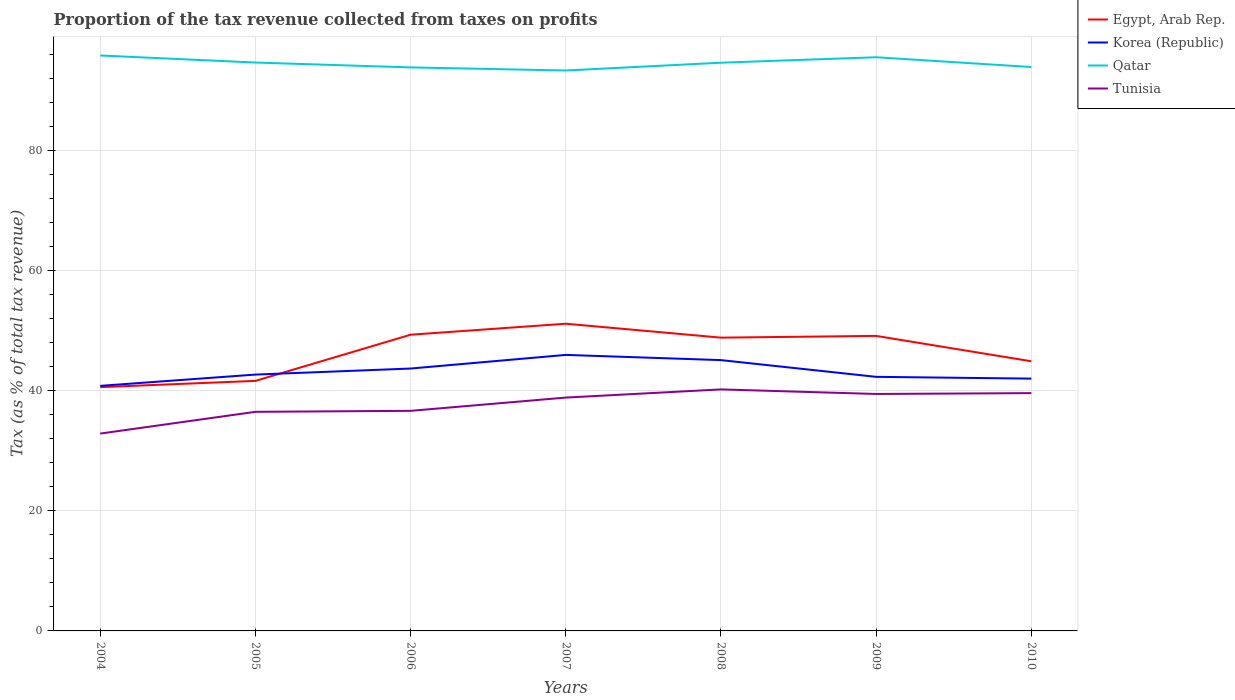Does the line corresponding to Qatar intersect with the line corresponding to Egypt, Arab Rep.?
Your answer should be very brief. No. Is the number of lines equal to the number of legend labels?
Your response must be concise. Yes. Across all years, what is the maximum proportion of the tax revenue collected in Tunisia?
Give a very brief answer. 32.89. In which year was the proportion of the tax revenue collected in Qatar maximum?
Your response must be concise. 2007. What is the total proportion of the tax revenue collected in Qatar in the graph?
Your answer should be compact. 1.33. What is the difference between the highest and the second highest proportion of the tax revenue collected in Tunisia?
Offer a terse response. 7.36. What is the difference between the highest and the lowest proportion of the tax revenue collected in Tunisia?
Keep it short and to the point. 4. Is the proportion of the tax revenue collected in Qatar strictly greater than the proportion of the tax revenue collected in Korea (Republic) over the years?
Your answer should be compact. No. How many lines are there?
Offer a very short reply. 4. Does the graph contain any zero values?
Provide a short and direct response. No. Does the graph contain grids?
Your answer should be compact. Yes. Where does the legend appear in the graph?
Give a very brief answer. Top right. How are the legend labels stacked?
Make the answer very short. Vertical. What is the title of the graph?
Provide a succinct answer. Proportion of the tax revenue collected from taxes on profits. What is the label or title of the Y-axis?
Offer a very short reply. Tax (as % of total tax revenue). What is the Tax (as % of total tax revenue) in Egypt, Arab Rep. in 2004?
Your answer should be very brief. 40.63. What is the Tax (as % of total tax revenue) in Korea (Republic) in 2004?
Your answer should be compact. 40.84. What is the Tax (as % of total tax revenue) of Qatar in 2004?
Keep it short and to the point. 95.9. What is the Tax (as % of total tax revenue) of Tunisia in 2004?
Your answer should be very brief. 32.89. What is the Tax (as % of total tax revenue) of Egypt, Arab Rep. in 2005?
Offer a terse response. 41.67. What is the Tax (as % of total tax revenue) of Korea (Republic) in 2005?
Keep it short and to the point. 42.72. What is the Tax (as % of total tax revenue) in Qatar in 2005?
Provide a succinct answer. 94.73. What is the Tax (as % of total tax revenue) in Tunisia in 2005?
Your response must be concise. 36.51. What is the Tax (as % of total tax revenue) of Egypt, Arab Rep. in 2006?
Provide a succinct answer. 49.37. What is the Tax (as % of total tax revenue) of Korea (Republic) in 2006?
Give a very brief answer. 43.73. What is the Tax (as % of total tax revenue) of Qatar in 2006?
Keep it short and to the point. 93.92. What is the Tax (as % of total tax revenue) in Tunisia in 2006?
Give a very brief answer. 36.68. What is the Tax (as % of total tax revenue) in Egypt, Arab Rep. in 2007?
Give a very brief answer. 51.2. What is the Tax (as % of total tax revenue) of Korea (Republic) in 2007?
Your answer should be compact. 46. What is the Tax (as % of total tax revenue) in Qatar in 2007?
Your answer should be compact. 93.4. What is the Tax (as % of total tax revenue) in Tunisia in 2007?
Offer a very short reply. 38.89. What is the Tax (as % of total tax revenue) in Egypt, Arab Rep. in 2008?
Provide a succinct answer. 48.88. What is the Tax (as % of total tax revenue) of Korea (Republic) in 2008?
Give a very brief answer. 45.13. What is the Tax (as % of total tax revenue) in Qatar in 2008?
Keep it short and to the point. 94.7. What is the Tax (as % of total tax revenue) of Tunisia in 2008?
Give a very brief answer. 40.25. What is the Tax (as % of total tax revenue) of Egypt, Arab Rep. in 2009?
Provide a succinct answer. 49.17. What is the Tax (as % of total tax revenue) of Korea (Republic) in 2009?
Make the answer very short. 42.34. What is the Tax (as % of total tax revenue) in Qatar in 2009?
Your response must be concise. 95.61. What is the Tax (as % of total tax revenue) in Tunisia in 2009?
Keep it short and to the point. 39.49. What is the Tax (as % of total tax revenue) of Egypt, Arab Rep. in 2010?
Give a very brief answer. 44.94. What is the Tax (as % of total tax revenue) in Korea (Republic) in 2010?
Give a very brief answer. 42.05. What is the Tax (as % of total tax revenue) in Qatar in 2010?
Keep it short and to the point. 93.98. What is the Tax (as % of total tax revenue) in Tunisia in 2010?
Keep it short and to the point. 39.63. Across all years, what is the maximum Tax (as % of total tax revenue) of Egypt, Arab Rep.?
Offer a terse response. 51.2. Across all years, what is the maximum Tax (as % of total tax revenue) in Korea (Republic)?
Offer a terse response. 46. Across all years, what is the maximum Tax (as % of total tax revenue) in Qatar?
Make the answer very short. 95.9. Across all years, what is the maximum Tax (as % of total tax revenue) of Tunisia?
Keep it short and to the point. 40.25. Across all years, what is the minimum Tax (as % of total tax revenue) of Egypt, Arab Rep.?
Your answer should be very brief. 40.63. Across all years, what is the minimum Tax (as % of total tax revenue) of Korea (Republic)?
Offer a very short reply. 40.84. Across all years, what is the minimum Tax (as % of total tax revenue) of Qatar?
Your response must be concise. 93.4. Across all years, what is the minimum Tax (as % of total tax revenue) in Tunisia?
Your answer should be very brief. 32.89. What is the total Tax (as % of total tax revenue) of Egypt, Arab Rep. in the graph?
Keep it short and to the point. 325.85. What is the total Tax (as % of total tax revenue) in Korea (Republic) in the graph?
Your answer should be compact. 302.82. What is the total Tax (as % of total tax revenue) in Qatar in the graph?
Offer a very short reply. 662.24. What is the total Tax (as % of total tax revenue) in Tunisia in the graph?
Your answer should be very brief. 264.35. What is the difference between the Tax (as % of total tax revenue) in Egypt, Arab Rep. in 2004 and that in 2005?
Make the answer very short. -1.05. What is the difference between the Tax (as % of total tax revenue) of Korea (Republic) in 2004 and that in 2005?
Make the answer very short. -1.88. What is the difference between the Tax (as % of total tax revenue) of Qatar in 2004 and that in 2005?
Keep it short and to the point. 1.18. What is the difference between the Tax (as % of total tax revenue) of Tunisia in 2004 and that in 2005?
Your answer should be compact. -3.62. What is the difference between the Tax (as % of total tax revenue) of Egypt, Arab Rep. in 2004 and that in 2006?
Offer a very short reply. -8.74. What is the difference between the Tax (as % of total tax revenue) in Korea (Republic) in 2004 and that in 2006?
Provide a succinct answer. -2.89. What is the difference between the Tax (as % of total tax revenue) in Qatar in 2004 and that in 2006?
Give a very brief answer. 1.99. What is the difference between the Tax (as % of total tax revenue) in Tunisia in 2004 and that in 2006?
Your answer should be very brief. -3.79. What is the difference between the Tax (as % of total tax revenue) in Egypt, Arab Rep. in 2004 and that in 2007?
Ensure brevity in your answer.  -10.57. What is the difference between the Tax (as % of total tax revenue) in Korea (Republic) in 2004 and that in 2007?
Your answer should be compact. -5.16. What is the difference between the Tax (as % of total tax revenue) of Qatar in 2004 and that in 2007?
Make the answer very short. 2.5. What is the difference between the Tax (as % of total tax revenue) in Tunisia in 2004 and that in 2007?
Offer a terse response. -6. What is the difference between the Tax (as % of total tax revenue) of Egypt, Arab Rep. in 2004 and that in 2008?
Keep it short and to the point. -8.25. What is the difference between the Tax (as % of total tax revenue) in Korea (Republic) in 2004 and that in 2008?
Provide a short and direct response. -4.29. What is the difference between the Tax (as % of total tax revenue) in Qatar in 2004 and that in 2008?
Make the answer very short. 1.2. What is the difference between the Tax (as % of total tax revenue) in Tunisia in 2004 and that in 2008?
Offer a terse response. -7.36. What is the difference between the Tax (as % of total tax revenue) of Egypt, Arab Rep. in 2004 and that in 2009?
Offer a very short reply. -8.54. What is the difference between the Tax (as % of total tax revenue) in Korea (Republic) in 2004 and that in 2009?
Provide a succinct answer. -1.5. What is the difference between the Tax (as % of total tax revenue) of Qatar in 2004 and that in 2009?
Provide a succinct answer. 0.29. What is the difference between the Tax (as % of total tax revenue) of Tunisia in 2004 and that in 2009?
Your answer should be compact. -6.6. What is the difference between the Tax (as % of total tax revenue) of Egypt, Arab Rep. in 2004 and that in 2010?
Offer a very short reply. -4.31. What is the difference between the Tax (as % of total tax revenue) in Korea (Republic) in 2004 and that in 2010?
Offer a very short reply. -1.21. What is the difference between the Tax (as % of total tax revenue) in Qatar in 2004 and that in 2010?
Provide a succinct answer. 1.92. What is the difference between the Tax (as % of total tax revenue) of Tunisia in 2004 and that in 2010?
Provide a succinct answer. -6.74. What is the difference between the Tax (as % of total tax revenue) of Egypt, Arab Rep. in 2005 and that in 2006?
Provide a short and direct response. -7.69. What is the difference between the Tax (as % of total tax revenue) in Korea (Republic) in 2005 and that in 2006?
Offer a very short reply. -1.01. What is the difference between the Tax (as % of total tax revenue) in Qatar in 2005 and that in 2006?
Ensure brevity in your answer.  0.81. What is the difference between the Tax (as % of total tax revenue) of Tunisia in 2005 and that in 2006?
Your answer should be very brief. -0.17. What is the difference between the Tax (as % of total tax revenue) of Egypt, Arab Rep. in 2005 and that in 2007?
Give a very brief answer. -9.53. What is the difference between the Tax (as % of total tax revenue) of Korea (Republic) in 2005 and that in 2007?
Keep it short and to the point. -3.28. What is the difference between the Tax (as % of total tax revenue) of Qatar in 2005 and that in 2007?
Offer a very short reply. 1.33. What is the difference between the Tax (as % of total tax revenue) of Tunisia in 2005 and that in 2007?
Provide a succinct answer. -2.38. What is the difference between the Tax (as % of total tax revenue) in Egypt, Arab Rep. in 2005 and that in 2008?
Your answer should be compact. -7.2. What is the difference between the Tax (as % of total tax revenue) in Korea (Republic) in 2005 and that in 2008?
Offer a terse response. -2.41. What is the difference between the Tax (as % of total tax revenue) of Qatar in 2005 and that in 2008?
Give a very brief answer. 0.03. What is the difference between the Tax (as % of total tax revenue) in Tunisia in 2005 and that in 2008?
Offer a terse response. -3.74. What is the difference between the Tax (as % of total tax revenue) in Egypt, Arab Rep. in 2005 and that in 2009?
Ensure brevity in your answer.  -7.5. What is the difference between the Tax (as % of total tax revenue) of Korea (Republic) in 2005 and that in 2009?
Offer a terse response. 0.38. What is the difference between the Tax (as % of total tax revenue) of Qatar in 2005 and that in 2009?
Provide a short and direct response. -0.88. What is the difference between the Tax (as % of total tax revenue) of Tunisia in 2005 and that in 2009?
Your answer should be very brief. -2.98. What is the difference between the Tax (as % of total tax revenue) in Egypt, Arab Rep. in 2005 and that in 2010?
Make the answer very short. -3.27. What is the difference between the Tax (as % of total tax revenue) in Korea (Republic) in 2005 and that in 2010?
Make the answer very short. 0.67. What is the difference between the Tax (as % of total tax revenue) in Qatar in 2005 and that in 2010?
Provide a short and direct response. 0.75. What is the difference between the Tax (as % of total tax revenue) in Tunisia in 2005 and that in 2010?
Your answer should be compact. -3.12. What is the difference between the Tax (as % of total tax revenue) in Egypt, Arab Rep. in 2006 and that in 2007?
Provide a short and direct response. -1.84. What is the difference between the Tax (as % of total tax revenue) of Korea (Republic) in 2006 and that in 2007?
Make the answer very short. -2.27. What is the difference between the Tax (as % of total tax revenue) in Qatar in 2006 and that in 2007?
Provide a short and direct response. 0.52. What is the difference between the Tax (as % of total tax revenue) of Tunisia in 2006 and that in 2007?
Give a very brief answer. -2.21. What is the difference between the Tax (as % of total tax revenue) of Egypt, Arab Rep. in 2006 and that in 2008?
Offer a very short reply. 0.49. What is the difference between the Tax (as % of total tax revenue) of Korea (Republic) in 2006 and that in 2008?
Make the answer very short. -1.4. What is the difference between the Tax (as % of total tax revenue) of Qatar in 2006 and that in 2008?
Offer a very short reply. -0.78. What is the difference between the Tax (as % of total tax revenue) in Tunisia in 2006 and that in 2008?
Your response must be concise. -3.57. What is the difference between the Tax (as % of total tax revenue) in Egypt, Arab Rep. in 2006 and that in 2009?
Provide a short and direct response. 0.2. What is the difference between the Tax (as % of total tax revenue) of Korea (Republic) in 2006 and that in 2009?
Your response must be concise. 1.39. What is the difference between the Tax (as % of total tax revenue) of Qatar in 2006 and that in 2009?
Your response must be concise. -1.69. What is the difference between the Tax (as % of total tax revenue) in Tunisia in 2006 and that in 2009?
Your answer should be very brief. -2.81. What is the difference between the Tax (as % of total tax revenue) in Egypt, Arab Rep. in 2006 and that in 2010?
Your response must be concise. 4.43. What is the difference between the Tax (as % of total tax revenue) of Korea (Republic) in 2006 and that in 2010?
Offer a terse response. 1.68. What is the difference between the Tax (as % of total tax revenue) in Qatar in 2006 and that in 2010?
Ensure brevity in your answer.  -0.06. What is the difference between the Tax (as % of total tax revenue) in Tunisia in 2006 and that in 2010?
Make the answer very short. -2.95. What is the difference between the Tax (as % of total tax revenue) in Egypt, Arab Rep. in 2007 and that in 2008?
Your response must be concise. 2.32. What is the difference between the Tax (as % of total tax revenue) of Korea (Republic) in 2007 and that in 2008?
Your answer should be compact. 0.87. What is the difference between the Tax (as % of total tax revenue) of Tunisia in 2007 and that in 2008?
Provide a short and direct response. -1.36. What is the difference between the Tax (as % of total tax revenue) in Egypt, Arab Rep. in 2007 and that in 2009?
Your answer should be compact. 2.03. What is the difference between the Tax (as % of total tax revenue) of Korea (Republic) in 2007 and that in 2009?
Provide a short and direct response. 3.66. What is the difference between the Tax (as % of total tax revenue) in Qatar in 2007 and that in 2009?
Your response must be concise. -2.21. What is the difference between the Tax (as % of total tax revenue) in Tunisia in 2007 and that in 2009?
Keep it short and to the point. -0.6. What is the difference between the Tax (as % of total tax revenue) of Egypt, Arab Rep. in 2007 and that in 2010?
Your answer should be compact. 6.26. What is the difference between the Tax (as % of total tax revenue) of Korea (Republic) in 2007 and that in 2010?
Your answer should be very brief. 3.95. What is the difference between the Tax (as % of total tax revenue) of Qatar in 2007 and that in 2010?
Make the answer very short. -0.58. What is the difference between the Tax (as % of total tax revenue) of Tunisia in 2007 and that in 2010?
Your answer should be very brief. -0.74. What is the difference between the Tax (as % of total tax revenue) of Egypt, Arab Rep. in 2008 and that in 2009?
Make the answer very short. -0.29. What is the difference between the Tax (as % of total tax revenue) of Korea (Republic) in 2008 and that in 2009?
Keep it short and to the point. 2.79. What is the difference between the Tax (as % of total tax revenue) of Qatar in 2008 and that in 2009?
Give a very brief answer. -0.91. What is the difference between the Tax (as % of total tax revenue) in Tunisia in 2008 and that in 2009?
Provide a short and direct response. 0.76. What is the difference between the Tax (as % of total tax revenue) of Egypt, Arab Rep. in 2008 and that in 2010?
Offer a terse response. 3.94. What is the difference between the Tax (as % of total tax revenue) of Korea (Republic) in 2008 and that in 2010?
Your response must be concise. 3.08. What is the difference between the Tax (as % of total tax revenue) in Qatar in 2008 and that in 2010?
Ensure brevity in your answer.  0.72. What is the difference between the Tax (as % of total tax revenue) in Tunisia in 2008 and that in 2010?
Give a very brief answer. 0.62. What is the difference between the Tax (as % of total tax revenue) in Egypt, Arab Rep. in 2009 and that in 2010?
Your response must be concise. 4.23. What is the difference between the Tax (as % of total tax revenue) of Korea (Republic) in 2009 and that in 2010?
Give a very brief answer. 0.29. What is the difference between the Tax (as % of total tax revenue) in Qatar in 2009 and that in 2010?
Make the answer very short. 1.63. What is the difference between the Tax (as % of total tax revenue) in Tunisia in 2009 and that in 2010?
Keep it short and to the point. -0.14. What is the difference between the Tax (as % of total tax revenue) of Egypt, Arab Rep. in 2004 and the Tax (as % of total tax revenue) of Korea (Republic) in 2005?
Your response must be concise. -2.09. What is the difference between the Tax (as % of total tax revenue) of Egypt, Arab Rep. in 2004 and the Tax (as % of total tax revenue) of Qatar in 2005?
Your answer should be compact. -54.1. What is the difference between the Tax (as % of total tax revenue) of Egypt, Arab Rep. in 2004 and the Tax (as % of total tax revenue) of Tunisia in 2005?
Your response must be concise. 4.11. What is the difference between the Tax (as % of total tax revenue) of Korea (Republic) in 2004 and the Tax (as % of total tax revenue) of Qatar in 2005?
Your response must be concise. -53.88. What is the difference between the Tax (as % of total tax revenue) of Korea (Republic) in 2004 and the Tax (as % of total tax revenue) of Tunisia in 2005?
Offer a terse response. 4.33. What is the difference between the Tax (as % of total tax revenue) of Qatar in 2004 and the Tax (as % of total tax revenue) of Tunisia in 2005?
Offer a very short reply. 59.39. What is the difference between the Tax (as % of total tax revenue) of Egypt, Arab Rep. in 2004 and the Tax (as % of total tax revenue) of Korea (Republic) in 2006?
Ensure brevity in your answer.  -3.1. What is the difference between the Tax (as % of total tax revenue) of Egypt, Arab Rep. in 2004 and the Tax (as % of total tax revenue) of Qatar in 2006?
Offer a terse response. -53.29. What is the difference between the Tax (as % of total tax revenue) in Egypt, Arab Rep. in 2004 and the Tax (as % of total tax revenue) in Tunisia in 2006?
Ensure brevity in your answer.  3.95. What is the difference between the Tax (as % of total tax revenue) of Korea (Republic) in 2004 and the Tax (as % of total tax revenue) of Qatar in 2006?
Make the answer very short. -53.07. What is the difference between the Tax (as % of total tax revenue) of Korea (Republic) in 2004 and the Tax (as % of total tax revenue) of Tunisia in 2006?
Provide a succinct answer. 4.16. What is the difference between the Tax (as % of total tax revenue) of Qatar in 2004 and the Tax (as % of total tax revenue) of Tunisia in 2006?
Provide a short and direct response. 59.22. What is the difference between the Tax (as % of total tax revenue) in Egypt, Arab Rep. in 2004 and the Tax (as % of total tax revenue) in Korea (Republic) in 2007?
Offer a terse response. -5.37. What is the difference between the Tax (as % of total tax revenue) in Egypt, Arab Rep. in 2004 and the Tax (as % of total tax revenue) in Qatar in 2007?
Ensure brevity in your answer.  -52.77. What is the difference between the Tax (as % of total tax revenue) in Egypt, Arab Rep. in 2004 and the Tax (as % of total tax revenue) in Tunisia in 2007?
Make the answer very short. 1.74. What is the difference between the Tax (as % of total tax revenue) of Korea (Republic) in 2004 and the Tax (as % of total tax revenue) of Qatar in 2007?
Keep it short and to the point. -52.56. What is the difference between the Tax (as % of total tax revenue) of Korea (Republic) in 2004 and the Tax (as % of total tax revenue) of Tunisia in 2007?
Keep it short and to the point. 1.95. What is the difference between the Tax (as % of total tax revenue) in Qatar in 2004 and the Tax (as % of total tax revenue) in Tunisia in 2007?
Provide a short and direct response. 57.01. What is the difference between the Tax (as % of total tax revenue) in Egypt, Arab Rep. in 2004 and the Tax (as % of total tax revenue) in Korea (Republic) in 2008?
Provide a short and direct response. -4.5. What is the difference between the Tax (as % of total tax revenue) in Egypt, Arab Rep. in 2004 and the Tax (as % of total tax revenue) in Qatar in 2008?
Your answer should be compact. -54.07. What is the difference between the Tax (as % of total tax revenue) in Egypt, Arab Rep. in 2004 and the Tax (as % of total tax revenue) in Tunisia in 2008?
Provide a succinct answer. 0.38. What is the difference between the Tax (as % of total tax revenue) in Korea (Republic) in 2004 and the Tax (as % of total tax revenue) in Qatar in 2008?
Keep it short and to the point. -53.86. What is the difference between the Tax (as % of total tax revenue) in Korea (Republic) in 2004 and the Tax (as % of total tax revenue) in Tunisia in 2008?
Keep it short and to the point. 0.59. What is the difference between the Tax (as % of total tax revenue) in Qatar in 2004 and the Tax (as % of total tax revenue) in Tunisia in 2008?
Make the answer very short. 55.65. What is the difference between the Tax (as % of total tax revenue) of Egypt, Arab Rep. in 2004 and the Tax (as % of total tax revenue) of Korea (Republic) in 2009?
Provide a succinct answer. -1.72. What is the difference between the Tax (as % of total tax revenue) in Egypt, Arab Rep. in 2004 and the Tax (as % of total tax revenue) in Qatar in 2009?
Ensure brevity in your answer.  -54.98. What is the difference between the Tax (as % of total tax revenue) in Egypt, Arab Rep. in 2004 and the Tax (as % of total tax revenue) in Tunisia in 2009?
Keep it short and to the point. 1.14. What is the difference between the Tax (as % of total tax revenue) of Korea (Republic) in 2004 and the Tax (as % of total tax revenue) of Qatar in 2009?
Provide a succinct answer. -54.77. What is the difference between the Tax (as % of total tax revenue) of Korea (Republic) in 2004 and the Tax (as % of total tax revenue) of Tunisia in 2009?
Your response must be concise. 1.35. What is the difference between the Tax (as % of total tax revenue) in Qatar in 2004 and the Tax (as % of total tax revenue) in Tunisia in 2009?
Provide a short and direct response. 56.41. What is the difference between the Tax (as % of total tax revenue) of Egypt, Arab Rep. in 2004 and the Tax (as % of total tax revenue) of Korea (Republic) in 2010?
Make the answer very short. -1.42. What is the difference between the Tax (as % of total tax revenue) of Egypt, Arab Rep. in 2004 and the Tax (as % of total tax revenue) of Qatar in 2010?
Make the answer very short. -53.35. What is the difference between the Tax (as % of total tax revenue) of Egypt, Arab Rep. in 2004 and the Tax (as % of total tax revenue) of Tunisia in 2010?
Offer a terse response. 1. What is the difference between the Tax (as % of total tax revenue) in Korea (Republic) in 2004 and the Tax (as % of total tax revenue) in Qatar in 2010?
Ensure brevity in your answer.  -53.13. What is the difference between the Tax (as % of total tax revenue) of Korea (Republic) in 2004 and the Tax (as % of total tax revenue) of Tunisia in 2010?
Offer a very short reply. 1.21. What is the difference between the Tax (as % of total tax revenue) of Qatar in 2004 and the Tax (as % of total tax revenue) of Tunisia in 2010?
Offer a very short reply. 56.27. What is the difference between the Tax (as % of total tax revenue) of Egypt, Arab Rep. in 2005 and the Tax (as % of total tax revenue) of Korea (Republic) in 2006?
Give a very brief answer. -2.06. What is the difference between the Tax (as % of total tax revenue) in Egypt, Arab Rep. in 2005 and the Tax (as % of total tax revenue) in Qatar in 2006?
Your answer should be very brief. -52.24. What is the difference between the Tax (as % of total tax revenue) in Egypt, Arab Rep. in 2005 and the Tax (as % of total tax revenue) in Tunisia in 2006?
Give a very brief answer. 4.99. What is the difference between the Tax (as % of total tax revenue) of Korea (Republic) in 2005 and the Tax (as % of total tax revenue) of Qatar in 2006?
Provide a succinct answer. -51.19. What is the difference between the Tax (as % of total tax revenue) of Korea (Republic) in 2005 and the Tax (as % of total tax revenue) of Tunisia in 2006?
Your answer should be very brief. 6.04. What is the difference between the Tax (as % of total tax revenue) of Qatar in 2005 and the Tax (as % of total tax revenue) of Tunisia in 2006?
Your response must be concise. 58.05. What is the difference between the Tax (as % of total tax revenue) of Egypt, Arab Rep. in 2005 and the Tax (as % of total tax revenue) of Korea (Republic) in 2007?
Give a very brief answer. -4.33. What is the difference between the Tax (as % of total tax revenue) of Egypt, Arab Rep. in 2005 and the Tax (as % of total tax revenue) of Qatar in 2007?
Ensure brevity in your answer.  -51.73. What is the difference between the Tax (as % of total tax revenue) in Egypt, Arab Rep. in 2005 and the Tax (as % of total tax revenue) in Tunisia in 2007?
Ensure brevity in your answer.  2.78. What is the difference between the Tax (as % of total tax revenue) of Korea (Republic) in 2005 and the Tax (as % of total tax revenue) of Qatar in 2007?
Your answer should be compact. -50.68. What is the difference between the Tax (as % of total tax revenue) of Korea (Republic) in 2005 and the Tax (as % of total tax revenue) of Tunisia in 2007?
Your answer should be very brief. 3.83. What is the difference between the Tax (as % of total tax revenue) in Qatar in 2005 and the Tax (as % of total tax revenue) in Tunisia in 2007?
Ensure brevity in your answer.  55.84. What is the difference between the Tax (as % of total tax revenue) in Egypt, Arab Rep. in 2005 and the Tax (as % of total tax revenue) in Korea (Republic) in 2008?
Offer a terse response. -3.46. What is the difference between the Tax (as % of total tax revenue) in Egypt, Arab Rep. in 2005 and the Tax (as % of total tax revenue) in Qatar in 2008?
Give a very brief answer. -53.03. What is the difference between the Tax (as % of total tax revenue) in Egypt, Arab Rep. in 2005 and the Tax (as % of total tax revenue) in Tunisia in 2008?
Offer a very short reply. 1.42. What is the difference between the Tax (as % of total tax revenue) in Korea (Republic) in 2005 and the Tax (as % of total tax revenue) in Qatar in 2008?
Give a very brief answer. -51.98. What is the difference between the Tax (as % of total tax revenue) of Korea (Republic) in 2005 and the Tax (as % of total tax revenue) of Tunisia in 2008?
Provide a succinct answer. 2.47. What is the difference between the Tax (as % of total tax revenue) of Qatar in 2005 and the Tax (as % of total tax revenue) of Tunisia in 2008?
Provide a short and direct response. 54.47. What is the difference between the Tax (as % of total tax revenue) in Egypt, Arab Rep. in 2005 and the Tax (as % of total tax revenue) in Korea (Republic) in 2009?
Ensure brevity in your answer.  -0.67. What is the difference between the Tax (as % of total tax revenue) in Egypt, Arab Rep. in 2005 and the Tax (as % of total tax revenue) in Qatar in 2009?
Your answer should be compact. -53.94. What is the difference between the Tax (as % of total tax revenue) of Egypt, Arab Rep. in 2005 and the Tax (as % of total tax revenue) of Tunisia in 2009?
Offer a very short reply. 2.18. What is the difference between the Tax (as % of total tax revenue) in Korea (Republic) in 2005 and the Tax (as % of total tax revenue) in Qatar in 2009?
Your answer should be very brief. -52.89. What is the difference between the Tax (as % of total tax revenue) in Korea (Republic) in 2005 and the Tax (as % of total tax revenue) in Tunisia in 2009?
Make the answer very short. 3.23. What is the difference between the Tax (as % of total tax revenue) of Qatar in 2005 and the Tax (as % of total tax revenue) of Tunisia in 2009?
Offer a terse response. 55.24. What is the difference between the Tax (as % of total tax revenue) in Egypt, Arab Rep. in 2005 and the Tax (as % of total tax revenue) in Korea (Republic) in 2010?
Your answer should be compact. -0.38. What is the difference between the Tax (as % of total tax revenue) of Egypt, Arab Rep. in 2005 and the Tax (as % of total tax revenue) of Qatar in 2010?
Provide a short and direct response. -52.31. What is the difference between the Tax (as % of total tax revenue) of Egypt, Arab Rep. in 2005 and the Tax (as % of total tax revenue) of Tunisia in 2010?
Make the answer very short. 2.04. What is the difference between the Tax (as % of total tax revenue) of Korea (Republic) in 2005 and the Tax (as % of total tax revenue) of Qatar in 2010?
Your answer should be compact. -51.26. What is the difference between the Tax (as % of total tax revenue) of Korea (Republic) in 2005 and the Tax (as % of total tax revenue) of Tunisia in 2010?
Keep it short and to the point. 3.09. What is the difference between the Tax (as % of total tax revenue) of Qatar in 2005 and the Tax (as % of total tax revenue) of Tunisia in 2010?
Give a very brief answer. 55.09. What is the difference between the Tax (as % of total tax revenue) of Egypt, Arab Rep. in 2006 and the Tax (as % of total tax revenue) of Korea (Republic) in 2007?
Provide a short and direct response. 3.36. What is the difference between the Tax (as % of total tax revenue) in Egypt, Arab Rep. in 2006 and the Tax (as % of total tax revenue) in Qatar in 2007?
Make the answer very short. -44.04. What is the difference between the Tax (as % of total tax revenue) of Egypt, Arab Rep. in 2006 and the Tax (as % of total tax revenue) of Tunisia in 2007?
Give a very brief answer. 10.47. What is the difference between the Tax (as % of total tax revenue) in Korea (Republic) in 2006 and the Tax (as % of total tax revenue) in Qatar in 2007?
Your answer should be compact. -49.67. What is the difference between the Tax (as % of total tax revenue) of Korea (Republic) in 2006 and the Tax (as % of total tax revenue) of Tunisia in 2007?
Your answer should be very brief. 4.84. What is the difference between the Tax (as % of total tax revenue) of Qatar in 2006 and the Tax (as % of total tax revenue) of Tunisia in 2007?
Your answer should be compact. 55.03. What is the difference between the Tax (as % of total tax revenue) of Egypt, Arab Rep. in 2006 and the Tax (as % of total tax revenue) of Korea (Republic) in 2008?
Your answer should be compact. 4.23. What is the difference between the Tax (as % of total tax revenue) in Egypt, Arab Rep. in 2006 and the Tax (as % of total tax revenue) in Qatar in 2008?
Ensure brevity in your answer.  -45.34. What is the difference between the Tax (as % of total tax revenue) of Egypt, Arab Rep. in 2006 and the Tax (as % of total tax revenue) of Tunisia in 2008?
Give a very brief answer. 9.11. What is the difference between the Tax (as % of total tax revenue) in Korea (Republic) in 2006 and the Tax (as % of total tax revenue) in Qatar in 2008?
Offer a very short reply. -50.97. What is the difference between the Tax (as % of total tax revenue) in Korea (Republic) in 2006 and the Tax (as % of total tax revenue) in Tunisia in 2008?
Provide a succinct answer. 3.48. What is the difference between the Tax (as % of total tax revenue) of Qatar in 2006 and the Tax (as % of total tax revenue) of Tunisia in 2008?
Your response must be concise. 53.66. What is the difference between the Tax (as % of total tax revenue) of Egypt, Arab Rep. in 2006 and the Tax (as % of total tax revenue) of Korea (Republic) in 2009?
Provide a short and direct response. 7.02. What is the difference between the Tax (as % of total tax revenue) in Egypt, Arab Rep. in 2006 and the Tax (as % of total tax revenue) in Qatar in 2009?
Offer a very short reply. -46.24. What is the difference between the Tax (as % of total tax revenue) of Egypt, Arab Rep. in 2006 and the Tax (as % of total tax revenue) of Tunisia in 2009?
Your answer should be compact. 9.87. What is the difference between the Tax (as % of total tax revenue) in Korea (Republic) in 2006 and the Tax (as % of total tax revenue) in Qatar in 2009?
Provide a succinct answer. -51.88. What is the difference between the Tax (as % of total tax revenue) in Korea (Republic) in 2006 and the Tax (as % of total tax revenue) in Tunisia in 2009?
Offer a terse response. 4.24. What is the difference between the Tax (as % of total tax revenue) in Qatar in 2006 and the Tax (as % of total tax revenue) in Tunisia in 2009?
Your answer should be compact. 54.43. What is the difference between the Tax (as % of total tax revenue) in Egypt, Arab Rep. in 2006 and the Tax (as % of total tax revenue) in Korea (Republic) in 2010?
Keep it short and to the point. 7.32. What is the difference between the Tax (as % of total tax revenue) of Egypt, Arab Rep. in 2006 and the Tax (as % of total tax revenue) of Qatar in 2010?
Provide a succinct answer. -44.61. What is the difference between the Tax (as % of total tax revenue) in Egypt, Arab Rep. in 2006 and the Tax (as % of total tax revenue) in Tunisia in 2010?
Your answer should be very brief. 9.73. What is the difference between the Tax (as % of total tax revenue) of Korea (Republic) in 2006 and the Tax (as % of total tax revenue) of Qatar in 2010?
Your response must be concise. -50.25. What is the difference between the Tax (as % of total tax revenue) in Korea (Republic) in 2006 and the Tax (as % of total tax revenue) in Tunisia in 2010?
Offer a very short reply. 4.1. What is the difference between the Tax (as % of total tax revenue) in Qatar in 2006 and the Tax (as % of total tax revenue) in Tunisia in 2010?
Keep it short and to the point. 54.28. What is the difference between the Tax (as % of total tax revenue) in Egypt, Arab Rep. in 2007 and the Tax (as % of total tax revenue) in Korea (Republic) in 2008?
Your answer should be compact. 6.07. What is the difference between the Tax (as % of total tax revenue) of Egypt, Arab Rep. in 2007 and the Tax (as % of total tax revenue) of Qatar in 2008?
Your answer should be very brief. -43.5. What is the difference between the Tax (as % of total tax revenue) in Egypt, Arab Rep. in 2007 and the Tax (as % of total tax revenue) in Tunisia in 2008?
Give a very brief answer. 10.95. What is the difference between the Tax (as % of total tax revenue) of Korea (Republic) in 2007 and the Tax (as % of total tax revenue) of Qatar in 2008?
Provide a succinct answer. -48.7. What is the difference between the Tax (as % of total tax revenue) in Korea (Republic) in 2007 and the Tax (as % of total tax revenue) in Tunisia in 2008?
Your answer should be compact. 5.75. What is the difference between the Tax (as % of total tax revenue) in Qatar in 2007 and the Tax (as % of total tax revenue) in Tunisia in 2008?
Make the answer very short. 53.15. What is the difference between the Tax (as % of total tax revenue) in Egypt, Arab Rep. in 2007 and the Tax (as % of total tax revenue) in Korea (Republic) in 2009?
Offer a very short reply. 8.86. What is the difference between the Tax (as % of total tax revenue) of Egypt, Arab Rep. in 2007 and the Tax (as % of total tax revenue) of Qatar in 2009?
Offer a very short reply. -44.41. What is the difference between the Tax (as % of total tax revenue) in Egypt, Arab Rep. in 2007 and the Tax (as % of total tax revenue) in Tunisia in 2009?
Make the answer very short. 11.71. What is the difference between the Tax (as % of total tax revenue) of Korea (Republic) in 2007 and the Tax (as % of total tax revenue) of Qatar in 2009?
Ensure brevity in your answer.  -49.61. What is the difference between the Tax (as % of total tax revenue) of Korea (Republic) in 2007 and the Tax (as % of total tax revenue) of Tunisia in 2009?
Offer a terse response. 6.51. What is the difference between the Tax (as % of total tax revenue) of Qatar in 2007 and the Tax (as % of total tax revenue) of Tunisia in 2009?
Ensure brevity in your answer.  53.91. What is the difference between the Tax (as % of total tax revenue) in Egypt, Arab Rep. in 2007 and the Tax (as % of total tax revenue) in Korea (Republic) in 2010?
Provide a succinct answer. 9.15. What is the difference between the Tax (as % of total tax revenue) of Egypt, Arab Rep. in 2007 and the Tax (as % of total tax revenue) of Qatar in 2010?
Offer a terse response. -42.78. What is the difference between the Tax (as % of total tax revenue) in Egypt, Arab Rep. in 2007 and the Tax (as % of total tax revenue) in Tunisia in 2010?
Keep it short and to the point. 11.57. What is the difference between the Tax (as % of total tax revenue) in Korea (Republic) in 2007 and the Tax (as % of total tax revenue) in Qatar in 2010?
Your response must be concise. -47.98. What is the difference between the Tax (as % of total tax revenue) of Korea (Republic) in 2007 and the Tax (as % of total tax revenue) of Tunisia in 2010?
Give a very brief answer. 6.37. What is the difference between the Tax (as % of total tax revenue) in Qatar in 2007 and the Tax (as % of total tax revenue) in Tunisia in 2010?
Offer a terse response. 53.77. What is the difference between the Tax (as % of total tax revenue) in Egypt, Arab Rep. in 2008 and the Tax (as % of total tax revenue) in Korea (Republic) in 2009?
Give a very brief answer. 6.53. What is the difference between the Tax (as % of total tax revenue) in Egypt, Arab Rep. in 2008 and the Tax (as % of total tax revenue) in Qatar in 2009?
Your answer should be compact. -46.73. What is the difference between the Tax (as % of total tax revenue) in Egypt, Arab Rep. in 2008 and the Tax (as % of total tax revenue) in Tunisia in 2009?
Your answer should be compact. 9.39. What is the difference between the Tax (as % of total tax revenue) of Korea (Republic) in 2008 and the Tax (as % of total tax revenue) of Qatar in 2009?
Your response must be concise. -50.48. What is the difference between the Tax (as % of total tax revenue) in Korea (Republic) in 2008 and the Tax (as % of total tax revenue) in Tunisia in 2009?
Make the answer very short. 5.64. What is the difference between the Tax (as % of total tax revenue) in Qatar in 2008 and the Tax (as % of total tax revenue) in Tunisia in 2009?
Your answer should be very brief. 55.21. What is the difference between the Tax (as % of total tax revenue) in Egypt, Arab Rep. in 2008 and the Tax (as % of total tax revenue) in Korea (Republic) in 2010?
Keep it short and to the point. 6.83. What is the difference between the Tax (as % of total tax revenue) in Egypt, Arab Rep. in 2008 and the Tax (as % of total tax revenue) in Qatar in 2010?
Your response must be concise. -45.1. What is the difference between the Tax (as % of total tax revenue) in Egypt, Arab Rep. in 2008 and the Tax (as % of total tax revenue) in Tunisia in 2010?
Offer a very short reply. 9.25. What is the difference between the Tax (as % of total tax revenue) in Korea (Republic) in 2008 and the Tax (as % of total tax revenue) in Qatar in 2010?
Provide a short and direct response. -48.85. What is the difference between the Tax (as % of total tax revenue) of Korea (Republic) in 2008 and the Tax (as % of total tax revenue) of Tunisia in 2010?
Your response must be concise. 5.5. What is the difference between the Tax (as % of total tax revenue) in Qatar in 2008 and the Tax (as % of total tax revenue) in Tunisia in 2010?
Provide a short and direct response. 55.07. What is the difference between the Tax (as % of total tax revenue) of Egypt, Arab Rep. in 2009 and the Tax (as % of total tax revenue) of Korea (Republic) in 2010?
Ensure brevity in your answer.  7.12. What is the difference between the Tax (as % of total tax revenue) in Egypt, Arab Rep. in 2009 and the Tax (as % of total tax revenue) in Qatar in 2010?
Your answer should be compact. -44.81. What is the difference between the Tax (as % of total tax revenue) in Egypt, Arab Rep. in 2009 and the Tax (as % of total tax revenue) in Tunisia in 2010?
Offer a terse response. 9.54. What is the difference between the Tax (as % of total tax revenue) in Korea (Republic) in 2009 and the Tax (as % of total tax revenue) in Qatar in 2010?
Make the answer very short. -51.63. What is the difference between the Tax (as % of total tax revenue) of Korea (Republic) in 2009 and the Tax (as % of total tax revenue) of Tunisia in 2010?
Your answer should be compact. 2.71. What is the difference between the Tax (as % of total tax revenue) in Qatar in 2009 and the Tax (as % of total tax revenue) in Tunisia in 2010?
Ensure brevity in your answer.  55.98. What is the average Tax (as % of total tax revenue) of Egypt, Arab Rep. per year?
Your answer should be compact. 46.55. What is the average Tax (as % of total tax revenue) in Korea (Republic) per year?
Provide a succinct answer. 43.26. What is the average Tax (as % of total tax revenue) in Qatar per year?
Give a very brief answer. 94.61. What is the average Tax (as % of total tax revenue) in Tunisia per year?
Your response must be concise. 37.76. In the year 2004, what is the difference between the Tax (as % of total tax revenue) of Egypt, Arab Rep. and Tax (as % of total tax revenue) of Korea (Republic)?
Your answer should be compact. -0.22. In the year 2004, what is the difference between the Tax (as % of total tax revenue) in Egypt, Arab Rep. and Tax (as % of total tax revenue) in Qatar?
Offer a very short reply. -55.28. In the year 2004, what is the difference between the Tax (as % of total tax revenue) in Egypt, Arab Rep. and Tax (as % of total tax revenue) in Tunisia?
Provide a short and direct response. 7.74. In the year 2004, what is the difference between the Tax (as % of total tax revenue) of Korea (Republic) and Tax (as % of total tax revenue) of Qatar?
Give a very brief answer. -55.06. In the year 2004, what is the difference between the Tax (as % of total tax revenue) of Korea (Republic) and Tax (as % of total tax revenue) of Tunisia?
Your answer should be compact. 7.95. In the year 2004, what is the difference between the Tax (as % of total tax revenue) in Qatar and Tax (as % of total tax revenue) in Tunisia?
Your response must be concise. 63.01. In the year 2005, what is the difference between the Tax (as % of total tax revenue) of Egypt, Arab Rep. and Tax (as % of total tax revenue) of Korea (Republic)?
Keep it short and to the point. -1.05. In the year 2005, what is the difference between the Tax (as % of total tax revenue) in Egypt, Arab Rep. and Tax (as % of total tax revenue) in Qatar?
Offer a very short reply. -53.05. In the year 2005, what is the difference between the Tax (as % of total tax revenue) of Egypt, Arab Rep. and Tax (as % of total tax revenue) of Tunisia?
Offer a very short reply. 5.16. In the year 2005, what is the difference between the Tax (as % of total tax revenue) of Korea (Republic) and Tax (as % of total tax revenue) of Qatar?
Provide a short and direct response. -52. In the year 2005, what is the difference between the Tax (as % of total tax revenue) in Korea (Republic) and Tax (as % of total tax revenue) in Tunisia?
Ensure brevity in your answer.  6.21. In the year 2005, what is the difference between the Tax (as % of total tax revenue) in Qatar and Tax (as % of total tax revenue) in Tunisia?
Make the answer very short. 58.21. In the year 2006, what is the difference between the Tax (as % of total tax revenue) in Egypt, Arab Rep. and Tax (as % of total tax revenue) in Korea (Republic)?
Your answer should be compact. 5.64. In the year 2006, what is the difference between the Tax (as % of total tax revenue) in Egypt, Arab Rep. and Tax (as % of total tax revenue) in Qatar?
Ensure brevity in your answer.  -44.55. In the year 2006, what is the difference between the Tax (as % of total tax revenue) of Egypt, Arab Rep. and Tax (as % of total tax revenue) of Tunisia?
Make the answer very short. 12.69. In the year 2006, what is the difference between the Tax (as % of total tax revenue) of Korea (Republic) and Tax (as % of total tax revenue) of Qatar?
Make the answer very short. -50.19. In the year 2006, what is the difference between the Tax (as % of total tax revenue) of Korea (Republic) and Tax (as % of total tax revenue) of Tunisia?
Your answer should be very brief. 7.05. In the year 2006, what is the difference between the Tax (as % of total tax revenue) in Qatar and Tax (as % of total tax revenue) in Tunisia?
Offer a terse response. 57.24. In the year 2007, what is the difference between the Tax (as % of total tax revenue) of Egypt, Arab Rep. and Tax (as % of total tax revenue) of Korea (Republic)?
Ensure brevity in your answer.  5.2. In the year 2007, what is the difference between the Tax (as % of total tax revenue) in Egypt, Arab Rep. and Tax (as % of total tax revenue) in Qatar?
Your response must be concise. -42.2. In the year 2007, what is the difference between the Tax (as % of total tax revenue) of Egypt, Arab Rep. and Tax (as % of total tax revenue) of Tunisia?
Offer a very short reply. 12.31. In the year 2007, what is the difference between the Tax (as % of total tax revenue) of Korea (Republic) and Tax (as % of total tax revenue) of Qatar?
Give a very brief answer. -47.4. In the year 2007, what is the difference between the Tax (as % of total tax revenue) of Korea (Republic) and Tax (as % of total tax revenue) of Tunisia?
Your response must be concise. 7.11. In the year 2007, what is the difference between the Tax (as % of total tax revenue) in Qatar and Tax (as % of total tax revenue) in Tunisia?
Provide a succinct answer. 54.51. In the year 2008, what is the difference between the Tax (as % of total tax revenue) in Egypt, Arab Rep. and Tax (as % of total tax revenue) in Korea (Republic)?
Provide a short and direct response. 3.75. In the year 2008, what is the difference between the Tax (as % of total tax revenue) in Egypt, Arab Rep. and Tax (as % of total tax revenue) in Qatar?
Your answer should be compact. -45.82. In the year 2008, what is the difference between the Tax (as % of total tax revenue) of Egypt, Arab Rep. and Tax (as % of total tax revenue) of Tunisia?
Make the answer very short. 8.63. In the year 2008, what is the difference between the Tax (as % of total tax revenue) in Korea (Republic) and Tax (as % of total tax revenue) in Qatar?
Make the answer very short. -49.57. In the year 2008, what is the difference between the Tax (as % of total tax revenue) in Korea (Republic) and Tax (as % of total tax revenue) in Tunisia?
Give a very brief answer. 4.88. In the year 2008, what is the difference between the Tax (as % of total tax revenue) in Qatar and Tax (as % of total tax revenue) in Tunisia?
Provide a succinct answer. 54.45. In the year 2009, what is the difference between the Tax (as % of total tax revenue) in Egypt, Arab Rep. and Tax (as % of total tax revenue) in Korea (Republic)?
Your answer should be very brief. 6.82. In the year 2009, what is the difference between the Tax (as % of total tax revenue) of Egypt, Arab Rep. and Tax (as % of total tax revenue) of Qatar?
Offer a terse response. -46.44. In the year 2009, what is the difference between the Tax (as % of total tax revenue) in Egypt, Arab Rep. and Tax (as % of total tax revenue) in Tunisia?
Your answer should be very brief. 9.68. In the year 2009, what is the difference between the Tax (as % of total tax revenue) in Korea (Republic) and Tax (as % of total tax revenue) in Qatar?
Offer a terse response. -53.27. In the year 2009, what is the difference between the Tax (as % of total tax revenue) of Korea (Republic) and Tax (as % of total tax revenue) of Tunisia?
Provide a succinct answer. 2.85. In the year 2009, what is the difference between the Tax (as % of total tax revenue) of Qatar and Tax (as % of total tax revenue) of Tunisia?
Offer a terse response. 56.12. In the year 2010, what is the difference between the Tax (as % of total tax revenue) of Egypt, Arab Rep. and Tax (as % of total tax revenue) of Korea (Republic)?
Your answer should be compact. 2.89. In the year 2010, what is the difference between the Tax (as % of total tax revenue) in Egypt, Arab Rep. and Tax (as % of total tax revenue) in Qatar?
Keep it short and to the point. -49.04. In the year 2010, what is the difference between the Tax (as % of total tax revenue) of Egypt, Arab Rep. and Tax (as % of total tax revenue) of Tunisia?
Give a very brief answer. 5.31. In the year 2010, what is the difference between the Tax (as % of total tax revenue) in Korea (Republic) and Tax (as % of total tax revenue) in Qatar?
Provide a short and direct response. -51.93. In the year 2010, what is the difference between the Tax (as % of total tax revenue) of Korea (Republic) and Tax (as % of total tax revenue) of Tunisia?
Provide a succinct answer. 2.42. In the year 2010, what is the difference between the Tax (as % of total tax revenue) of Qatar and Tax (as % of total tax revenue) of Tunisia?
Your answer should be very brief. 54.35. What is the ratio of the Tax (as % of total tax revenue) in Egypt, Arab Rep. in 2004 to that in 2005?
Offer a very short reply. 0.97. What is the ratio of the Tax (as % of total tax revenue) in Korea (Republic) in 2004 to that in 2005?
Give a very brief answer. 0.96. What is the ratio of the Tax (as % of total tax revenue) in Qatar in 2004 to that in 2005?
Your answer should be very brief. 1.01. What is the ratio of the Tax (as % of total tax revenue) of Tunisia in 2004 to that in 2005?
Make the answer very short. 0.9. What is the ratio of the Tax (as % of total tax revenue) in Egypt, Arab Rep. in 2004 to that in 2006?
Offer a very short reply. 0.82. What is the ratio of the Tax (as % of total tax revenue) of Korea (Republic) in 2004 to that in 2006?
Provide a succinct answer. 0.93. What is the ratio of the Tax (as % of total tax revenue) of Qatar in 2004 to that in 2006?
Ensure brevity in your answer.  1.02. What is the ratio of the Tax (as % of total tax revenue) in Tunisia in 2004 to that in 2006?
Ensure brevity in your answer.  0.9. What is the ratio of the Tax (as % of total tax revenue) of Egypt, Arab Rep. in 2004 to that in 2007?
Provide a short and direct response. 0.79. What is the ratio of the Tax (as % of total tax revenue) in Korea (Republic) in 2004 to that in 2007?
Ensure brevity in your answer.  0.89. What is the ratio of the Tax (as % of total tax revenue) in Qatar in 2004 to that in 2007?
Your answer should be very brief. 1.03. What is the ratio of the Tax (as % of total tax revenue) of Tunisia in 2004 to that in 2007?
Make the answer very short. 0.85. What is the ratio of the Tax (as % of total tax revenue) in Egypt, Arab Rep. in 2004 to that in 2008?
Your response must be concise. 0.83. What is the ratio of the Tax (as % of total tax revenue) of Korea (Republic) in 2004 to that in 2008?
Make the answer very short. 0.91. What is the ratio of the Tax (as % of total tax revenue) in Qatar in 2004 to that in 2008?
Make the answer very short. 1.01. What is the ratio of the Tax (as % of total tax revenue) of Tunisia in 2004 to that in 2008?
Give a very brief answer. 0.82. What is the ratio of the Tax (as % of total tax revenue) in Egypt, Arab Rep. in 2004 to that in 2009?
Offer a very short reply. 0.83. What is the ratio of the Tax (as % of total tax revenue) in Korea (Republic) in 2004 to that in 2009?
Your response must be concise. 0.96. What is the ratio of the Tax (as % of total tax revenue) in Qatar in 2004 to that in 2009?
Provide a short and direct response. 1. What is the ratio of the Tax (as % of total tax revenue) in Tunisia in 2004 to that in 2009?
Ensure brevity in your answer.  0.83. What is the ratio of the Tax (as % of total tax revenue) in Egypt, Arab Rep. in 2004 to that in 2010?
Provide a short and direct response. 0.9. What is the ratio of the Tax (as % of total tax revenue) in Korea (Republic) in 2004 to that in 2010?
Give a very brief answer. 0.97. What is the ratio of the Tax (as % of total tax revenue) in Qatar in 2004 to that in 2010?
Keep it short and to the point. 1.02. What is the ratio of the Tax (as % of total tax revenue) in Tunisia in 2004 to that in 2010?
Make the answer very short. 0.83. What is the ratio of the Tax (as % of total tax revenue) of Egypt, Arab Rep. in 2005 to that in 2006?
Your answer should be very brief. 0.84. What is the ratio of the Tax (as % of total tax revenue) of Qatar in 2005 to that in 2006?
Provide a short and direct response. 1.01. What is the ratio of the Tax (as % of total tax revenue) of Egypt, Arab Rep. in 2005 to that in 2007?
Offer a terse response. 0.81. What is the ratio of the Tax (as % of total tax revenue) of Korea (Republic) in 2005 to that in 2007?
Provide a succinct answer. 0.93. What is the ratio of the Tax (as % of total tax revenue) of Qatar in 2005 to that in 2007?
Offer a terse response. 1.01. What is the ratio of the Tax (as % of total tax revenue) in Tunisia in 2005 to that in 2007?
Ensure brevity in your answer.  0.94. What is the ratio of the Tax (as % of total tax revenue) in Egypt, Arab Rep. in 2005 to that in 2008?
Make the answer very short. 0.85. What is the ratio of the Tax (as % of total tax revenue) of Korea (Republic) in 2005 to that in 2008?
Keep it short and to the point. 0.95. What is the ratio of the Tax (as % of total tax revenue) of Tunisia in 2005 to that in 2008?
Offer a terse response. 0.91. What is the ratio of the Tax (as % of total tax revenue) of Egypt, Arab Rep. in 2005 to that in 2009?
Give a very brief answer. 0.85. What is the ratio of the Tax (as % of total tax revenue) of Korea (Republic) in 2005 to that in 2009?
Provide a short and direct response. 1.01. What is the ratio of the Tax (as % of total tax revenue) in Qatar in 2005 to that in 2009?
Give a very brief answer. 0.99. What is the ratio of the Tax (as % of total tax revenue) in Tunisia in 2005 to that in 2009?
Provide a short and direct response. 0.92. What is the ratio of the Tax (as % of total tax revenue) in Egypt, Arab Rep. in 2005 to that in 2010?
Your answer should be compact. 0.93. What is the ratio of the Tax (as % of total tax revenue) in Tunisia in 2005 to that in 2010?
Your answer should be compact. 0.92. What is the ratio of the Tax (as % of total tax revenue) of Egypt, Arab Rep. in 2006 to that in 2007?
Provide a succinct answer. 0.96. What is the ratio of the Tax (as % of total tax revenue) in Korea (Republic) in 2006 to that in 2007?
Make the answer very short. 0.95. What is the ratio of the Tax (as % of total tax revenue) in Qatar in 2006 to that in 2007?
Provide a succinct answer. 1.01. What is the ratio of the Tax (as % of total tax revenue) in Tunisia in 2006 to that in 2007?
Provide a short and direct response. 0.94. What is the ratio of the Tax (as % of total tax revenue) in Egypt, Arab Rep. in 2006 to that in 2008?
Offer a very short reply. 1.01. What is the ratio of the Tax (as % of total tax revenue) in Korea (Republic) in 2006 to that in 2008?
Ensure brevity in your answer.  0.97. What is the ratio of the Tax (as % of total tax revenue) in Qatar in 2006 to that in 2008?
Your answer should be compact. 0.99. What is the ratio of the Tax (as % of total tax revenue) in Tunisia in 2006 to that in 2008?
Your answer should be very brief. 0.91. What is the ratio of the Tax (as % of total tax revenue) of Egypt, Arab Rep. in 2006 to that in 2009?
Your answer should be very brief. 1. What is the ratio of the Tax (as % of total tax revenue) of Korea (Republic) in 2006 to that in 2009?
Offer a very short reply. 1.03. What is the ratio of the Tax (as % of total tax revenue) of Qatar in 2006 to that in 2009?
Give a very brief answer. 0.98. What is the ratio of the Tax (as % of total tax revenue) of Tunisia in 2006 to that in 2009?
Make the answer very short. 0.93. What is the ratio of the Tax (as % of total tax revenue) in Egypt, Arab Rep. in 2006 to that in 2010?
Your answer should be very brief. 1.1. What is the ratio of the Tax (as % of total tax revenue) of Korea (Republic) in 2006 to that in 2010?
Ensure brevity in your answer.  1.04. What is the ratio of the Tax (as % of total tax revenue) in Qatar in 2006 to that in 2010?
Provide a short and direct response. 1. What is the ratio of the Tax (as % of total tax revenue) in Tunisia in 2006 to that in 2010?
Keep it short and to the point. 0.93. What is the ratio of the Tax (as % of total tax revenue) in Egypt, Arab Rep. in 2007 to that in 2008?
Provide a short and direct response. 1.05. What is the ratio of the Tax (as % of total tax revenue) of Korea (Republic) in 2007 to that in 2008?
Give a very brief answer. 1.02. What is the ratio of the Tax (as % of total tax revenue) of Qatar in 2007 to that in 2008?
Your answer should be very brief. 0.99. What is the ratio of the Tax (as % of total tax revenue) in Tunisia in 2007 to that in 2008?
Your response must be concise. 0.97. What is the ratio of the Tax (as % of total tax revenue) of Egypt, Arab Rep. in 2007 to that in 2009?
Give a very brief answer. 1.04. What is the ratio of the Tax (as % of total tax revenue) in Korea (Republic) in 2007 to that in 2009?
Make the answer very short. 1.09. What is the ratio of the Tax (as % of total tax revenue) of Qatar in 2007 to that in 2009?
Provide a succinct answer. 0.98. What is the ratio of the Tax (as % of total tax revenue) of Egypt, Arab Rep. in 2007 to that in 2010?
Provide a short and direct response. 1.14. What is the ratio of the Tax (as % of total tax revenue) of Korea (Republic) in 2007 to that in 2010?
Offer a very short reply. 1.09. What is the ratio of the Tax (as % of total tax revenue) of Tunisia in 2007 to that in 2010?
Your answer should be compact. 0.98. What is the ratio of the Tax (as % of total tax revenue) of Egypt, Arab Rep. in 2008 to that in 2009?
Offer a terse response. 0.99. What is the ratio of the Tax (as % of total tax revenue) of Korea (Republic) in 2008 to that in 2009?
Your answer should be very brief. 1.07. What is the ratio of the Tax (as % of total tax revenue) of Tunisia in 2008 to that in 2009?
Make the answer very short. 1.02. What is the ratio of the Tax (as % of total tax revenue) in Egypt, Arab Rep. in 2008 to that in 2010?
Provide a succinct answer. 1.09. What is the ratio of the Tax (as % of total tax revenue) in Korea (Republic) in 2008 to that in 2010?
Give a very brief answer. 1.07. What is the ratio of the Tax (as % of total tax revenue) of Qatar in 2008 to that in 2010?
Provide a short and direct response. 1.01. What is the ratio of the Tax (as % of total tax revenue) in Tunisia in 2008 to that in 2010?
Provide a short and direct response. 1.02. What is the ratio of the Tax (as % of total tax revenue) of Egypt, Arab Rep. in 2009 to that in 2010?
Provide a short and direct response. 1.09. What is the ratio of the Tax (as % of total tax revenue) of Qatar in 2009 to that in 2010?
Your response must be concise. 1.02. What is the difference between the highest and the second highest Tax (as % of total tax revenue) of Egypt, Arab Rep.?
Your answer should be compact. 1.84. What is the difference between the highest and the second highest Tax (as % of total tax revenue) of Korea (Republic)?
Make the answer very short. 0.87. What is the difference between the highest and the second highest Tax (as % of total tax revenue) in Qatar?
Your response must be concise. 0.29. What is the difference between the highest and the second highest Tax (as % of total tax revenue) of Tunisia?
Offer a terse response. 0.62. What is the difference between the highest and the lowest Tax (as % of total tax revenue) in Egypt, Arab Rep.?
Provide a short and direct response. 10.57. What is the difference between the highest and the lowest Tax (as % of total tax revenue) in Korea (Republic)?
Keep it short and to the point. 5.16. What is the difference between the highest and the lowest Tax (as % of total tax revenue) in Qatar?
Give a very brief answer. 2.5. What is the difference between the highest and the lowest Tax (as % of total tax revenue) in Tunisia?
Provide a short and direct response. 7.36. 